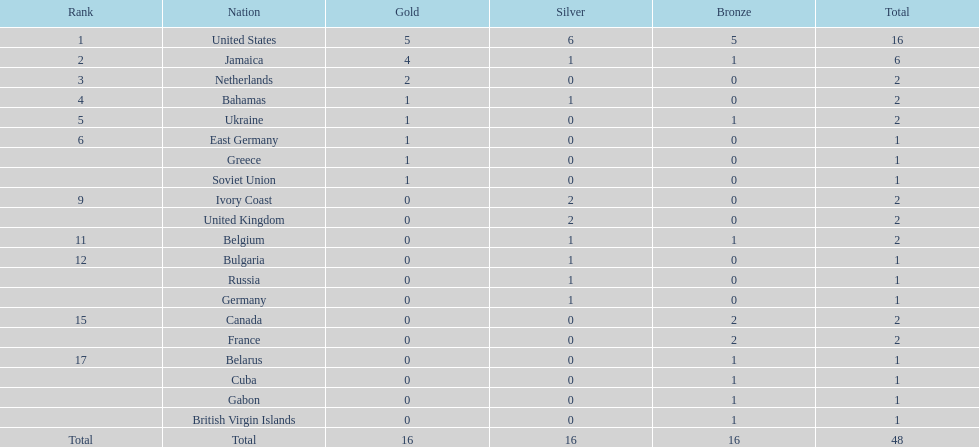What is the overall count of gold medals jamaica has secured? 4. 